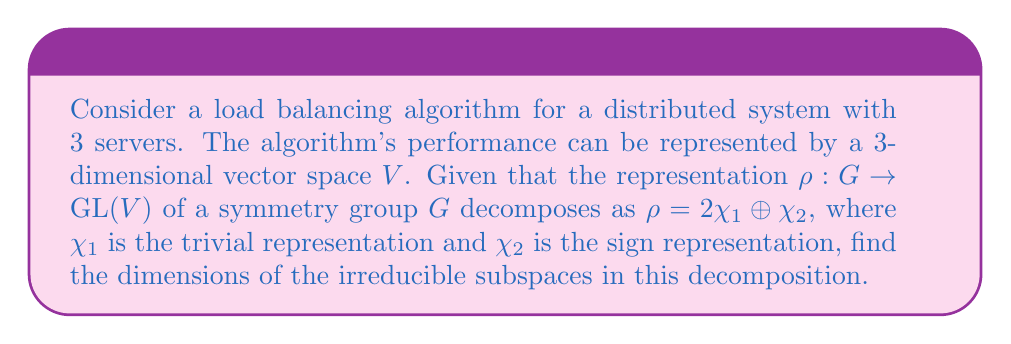Give your solution to this math problem. To solve this problem, we'll follow these steps:

1) First, recall that the dimension of the representation space $V$ is equal to the sum of the dimensions of its irreducible components:

   $\dim(V) = 2\dim(\chi_1) + \dim(\chi_2)$

2) We know that $V$ is 3-dimensional, so:

   $3 = 2\dim(\chi_1) + \dim(\chi_2)$

3) The trivial representation $\chi_1$ always has dimension 1:

   $\dim(\chi_1) = 1$

4) Substituting this into our equation:

   $3 = 2(1) + \dim(\chi_2)$

5) Solving for $\dim(\chi_2)$:

   $\dim(\chi_2) = 3 - 2 = 1$

6) Therefore, the decomposition consists of:
   - Two 1-dimensional subspaces corresponding to $\chi_1$
   - One 1-dimensional subspace corresponding to $\chi_2$

This decomposition reflects how the load balancing algorithm's performance space can be broken down into simpler, symmetry-preserving components.
Answer: $(1,1,1)$ 